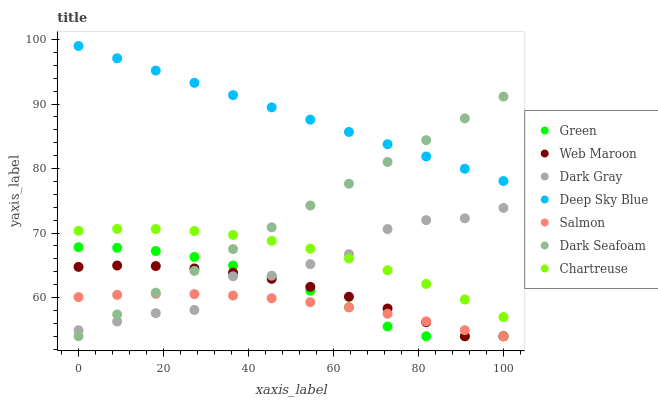Does Salmon have the minimum area under the curve?
Answer yes or no. Yes. Does Deep Sky Blue have the maximum area under the curve?
Answer yes or no. Yes. Does Web Maroon have the minimum area under the curve?
Answer yes or no. No. Does Web Maroon have the maximum area under the curve?
Answer yes or no. No. Is Dark Seafoam the smoothest?
Answer yes or no. Yes. Is Dark Gray the roughest?
Answer yes or no. Yes. Is Web Maroon the smoothest?
Answer yes or no. No. Is Web Maroon the roughest?
Answer yes or no. No. Does Salmon have the lowest value?
Answer yes or no. Yes. Does Chartreuse have the lowest value?
Answer yes or no. No. Does Deep Sky Blue have the highest value?
Answer yes or no. Yes. Does Web Maroon have the highest value?
Answer yes or no. No. Is Salmon less than Deep Sky Blue?
Answer yes or no. Yes. Is Deep Sky Blue greater than Salmon?
Answer yes or no. Yes. Does Web Maroon intersect Dark Gray?
Answer yes or no. Yes. Is Web Maroon less than Dark Gray?
Answer yes or no. No. Is Web Maroon greater than Dark Gray?
Answer yes or no. No. Does Salmon intersect Deep Sky Blue?
Answer yes or no. No. 